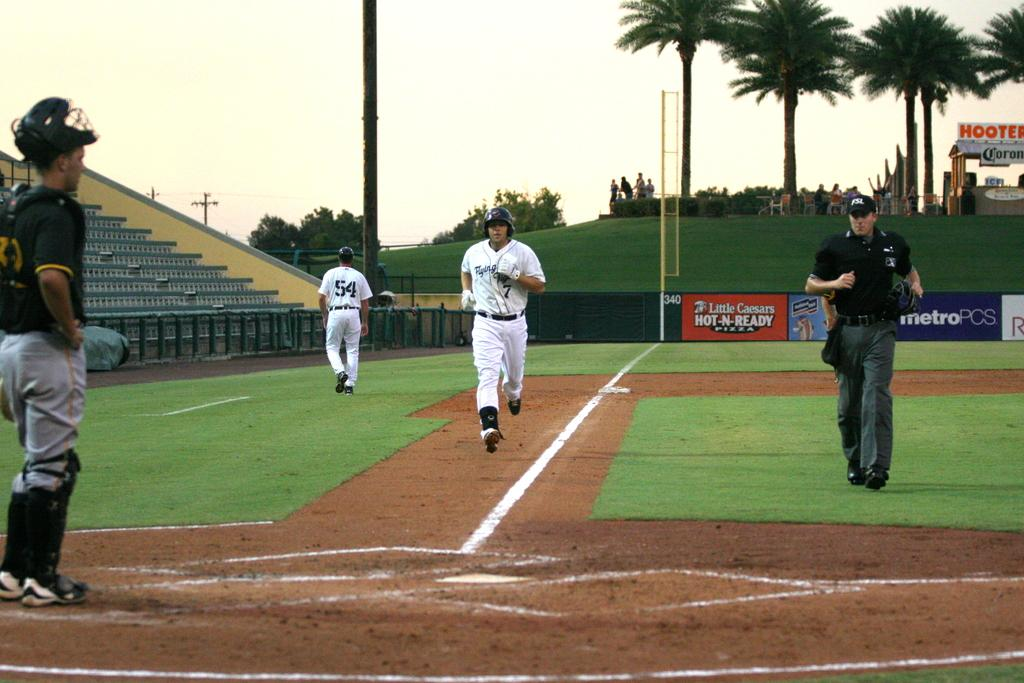Provide a one-sentence caption for the provided image. A base runner for the Flying Tigers baseball team running to home base while a catcher from the other team stands and watches. 